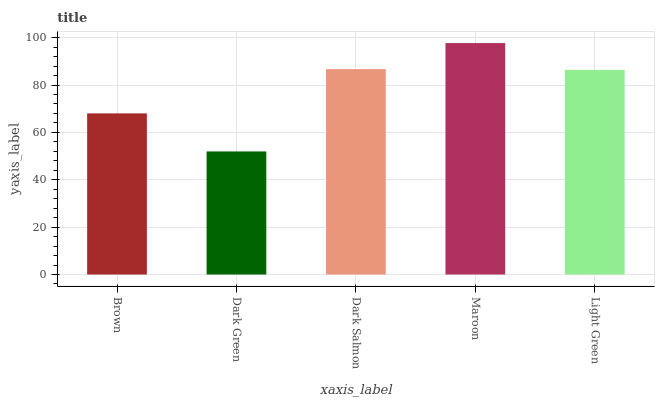Is Dark Salmon the minimum?
Answer yes or no. No. Is Dark Salmon the maximum?
Answer yes or no. No. Is Dark Salmon greater than Dark Green?
Answer yes or no. Yes. Is Dark Green less than Dark Salmon?
Answer yes or no. Yes. Is Dark Green greater than Dark Salmon?
Answer yes or no. No. Is Dark Salmon less than Dark Green?
Answer yes or no. No. Is Light Green the high median?
Answer yes or no. Yes. Is Light Green the low median?
Answer yes or no. Yes. Is Dark Green the high median?
Answer yes or no. No. Is Dark Salmon the low median?
Answer yes or no. No. 